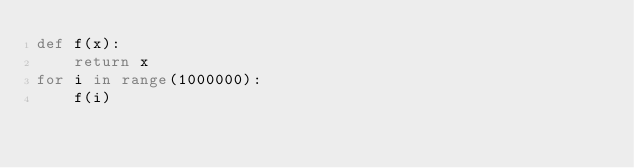<code> <loc_0><loc_0><loc_500><loc_500><_Python_>def f(x):
    return x
for i in range(1000000):
    f(i)

</code> 